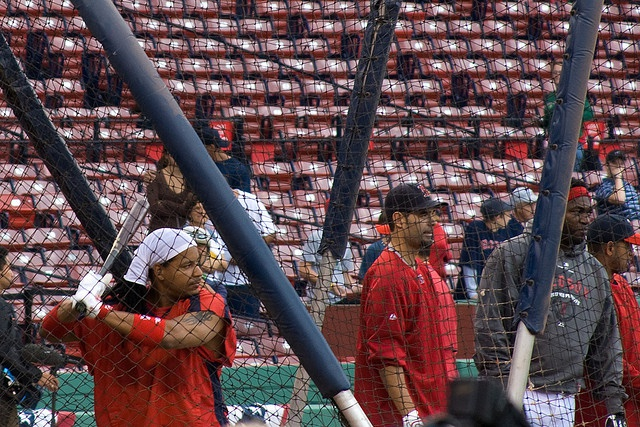Describe the objects in this image and their specific colors. I can see people in brown, maroon, black, and lavender tones, people in brown, black, gray, and darkgray tones, people in brown, maroon, and black tones, people in brown, black, and maroon tones, and people in brown, black, lavender, darkgray, and gray tones in this image. 